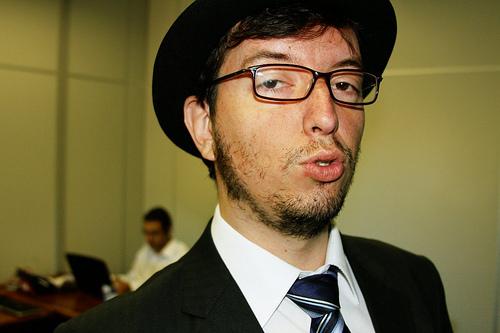How many eyes does this man have?
Concise answer only. 2. Does this person have glasses?
Quick response, please. Yes. What ethnicity is the man?
Keep it brief. Caucasian. What color is the man's tie?
Answer briefly. Blue. Does this man need to shave?
Concise answer only. Yes. 